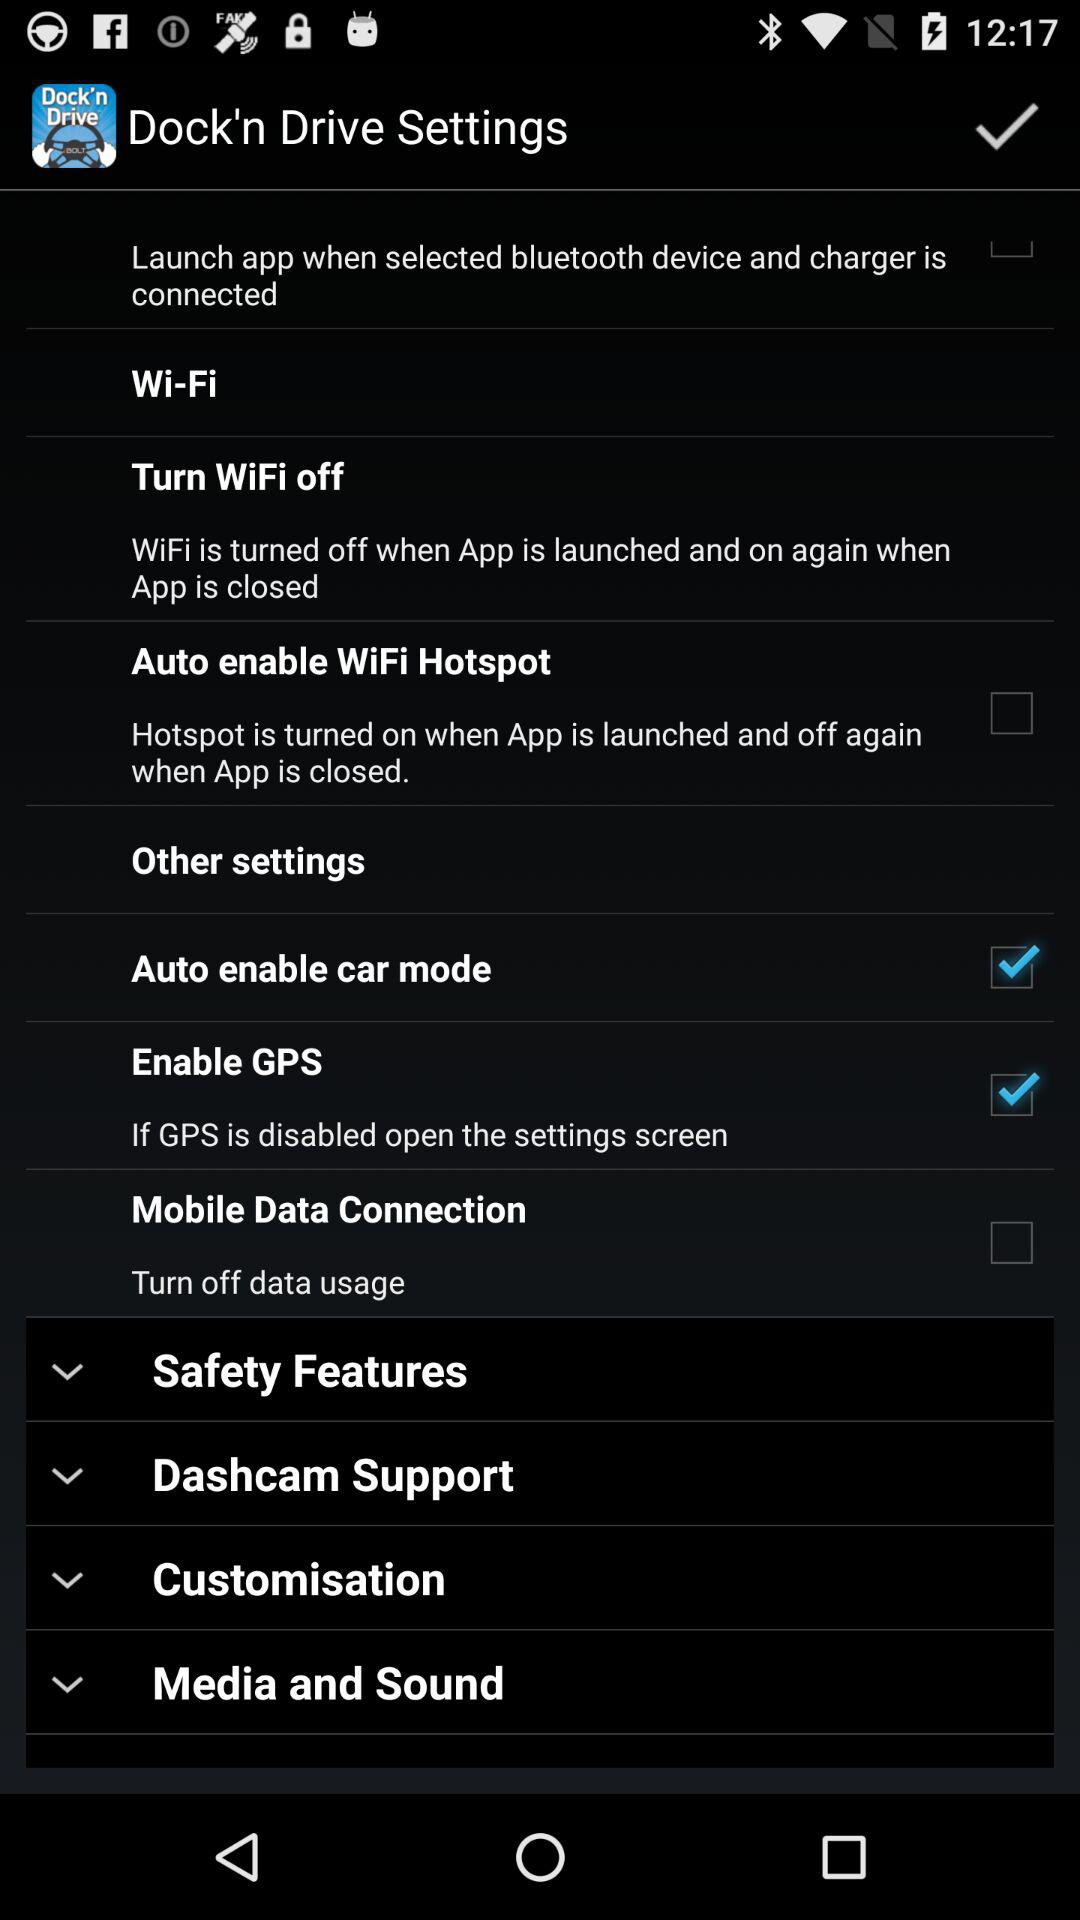What are the safety features?
When the provided information is insufficient, respond with <no answer>. <no answer> 